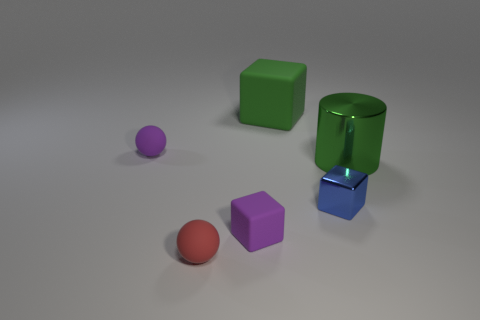What number of other objects are there of the same shape as the tiny blue metal object?
Give a very brief answer. 2. What is the shape of the tiny purple object that is in front of the large green object right of the tiny metallic cube in front of the purple matte ball?
Provide a succinct answer. Cube. What number of blocks are tiny blue metallic things or purple things?
Provide a succinct answer. 2. There is a matte cube that is behind the purple cube; are there any purple balls behind it?
Provide a succinct answer. No. Do the tiny red thing and the green object on the left side of the large green metallic cylinder have the same shape?
Ensure brevity in your answer.  No. What number of other things are the same size as the red matte thing?
Your answer should be very brief. 3. How many purple things are either large matte objects or small rubber blocks?
Provide a short and direct response. 1. What number of tiny things are right of the green matte thing and behind the small blue thing?
Offer a terse response. 0. What material is the block right of the big green object that is left of the cube on the right side of the large block?
Your answer should be very brief. Metal. What number of blue objects have the same material as the big cylinder?
Provide a succinct answer. 1. 